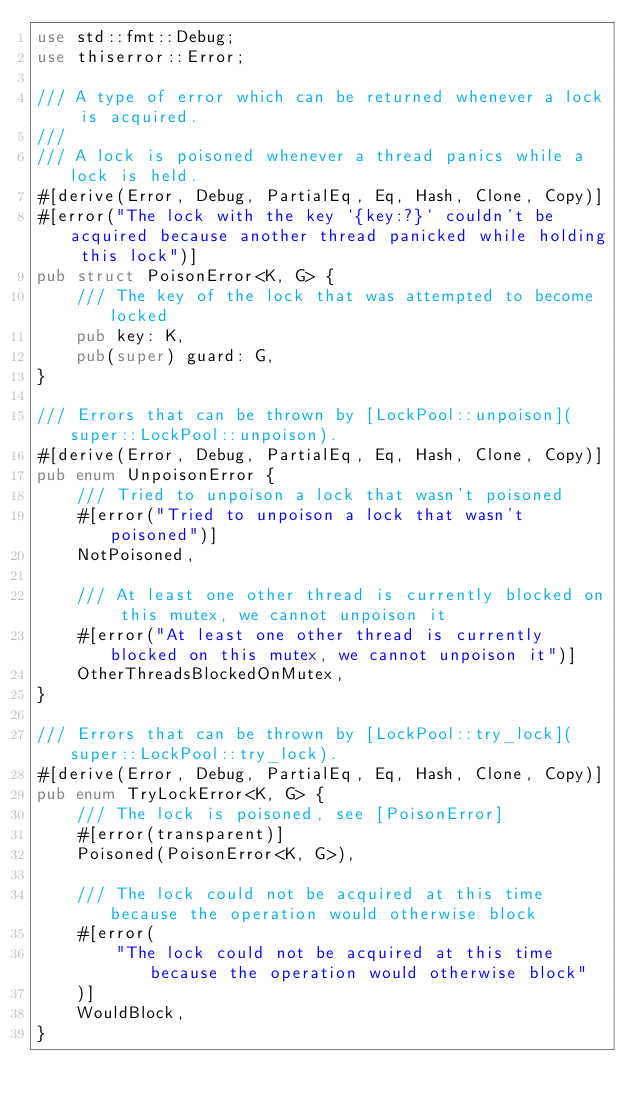<code> <loc_0><loc_0><loc_500><loc_500><_Rust_>use std::fmt::Debug;
use thiserror::Error;

/// A type of error which can be returned whenever a lock is acquired.
///
/// A lock is poisoned whenever a thread panics while a lock is held.
#[derive(Error, Debug, PartialEq, Eq, Hash, Clone, Copy)]
#[error("The lock with the key `{key:?}` couldn't be acquired because another thread panicked while holding this lock")]
pub struct PoisonError<K, G> {
    /// The key of the lock that was attempted to become locked
    pub key: K,
    pub(super) guard: G,
}

/// Errors that can be thrown by [LockPool::unpoison](super::LockPool::unpoison).
#[derive(Error, Debug, PartialEq, Eq, Hash, Clone, Copy)]
pub enum UnpoisonError {
    /// Tried to unpoison a lock that wasn't poisoned
    #[error("Tried to unpoison a lock that wasn't poisoned")]
    NotPoisoned,

    /// At least one other thread is currently blocked on this mutex, we cannot unpoison it
    #[error("At least one other thread is currently blocked on this mutex, we cannot unpoison it")]
    OtherThreadsBlockedOnMutex,
}

/// Errors that can be thrown by [LockPool::try_lock](super::LockPool::try_lock).
#[derive(Error, Debug, PartialEq, Eq, Hash, Clone, Copy)]
pub enum TryLockError<K, G> {
    /// The lock is poisoned, see [PoisonError]
    #[error(transparent)]
    Poisoned(PoisonError<K, G>),

    /// The lock could not be acquired at this time because the operation would otherwise block
    #[error(
        "The lock could not be acquired at this time because the operation would otherwise block"
    )]
    WouldBlock,
}
</code> 